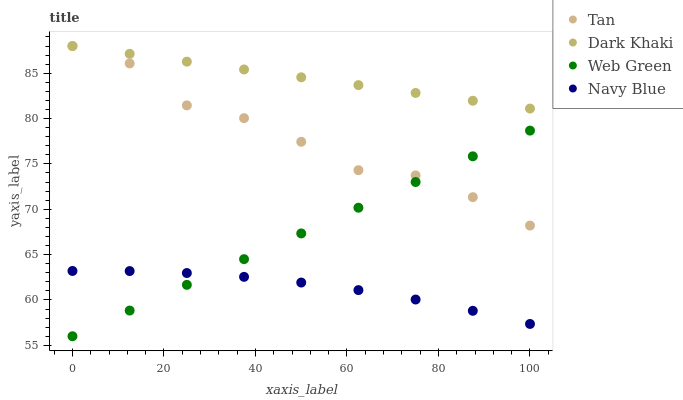Does Navy Blue have the minimum area under the curve?
Answer yes or no. Yes. Does Dark Khaki have the maximum area under the curve?
Answer yes or no. Yes. Does Tan have the minimum area under the curve?
Answer yes or no. No. Does Tan have the maximum area under the curve?
Answer yes or no. No. Is Web Green the smoothest?
Answer yes or no. Yes. Is Tan the roughest?
Answer yes or no. Yes. Is Navy Blue the smoothest?
Answer yes or no. No. Is Navy Blue the roughest?
Answer yes or no. No. Does Web Green have the lowest value?
Answer yes or no. Yes. Does Navy Blue have the lowest value?
Answer yes or no. No. Does Tan have the highest value?
Answer yes or no. Yes. Does Navy Blue have the highest value?
Answer yes or no. No. Is Web Green less than Dark Khaki?
Answer yes or no. Yes. Is Dark Khaki greater than Web Green?
Answer yes or no. Yes. Does Tan intersect Dark Khaki?
Answer yes or no. Yes. Is Tan less than Dark Khaki?
Answer yes or no. No. Is Tan greater than Dark Khaki?
Answer yes or no. No. Does Web Green intersect Dark Khaki?
Answer yes or no. No. 